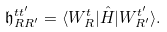Convert formula to latex. <formula><loc_0><loc_0><loc_500><loc_500>\mathfrak { h } _ { { R } { R } ^ { \prime } } ^ { t t ^ { \prime } } = \langle W _ { R } ^ { t } | \hat { H } | W _ { { R } ^ { \prime } } ^ { t ^ { \prime } } \rangle .</formula> 